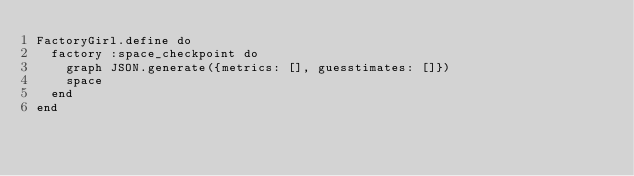<code> <loc_0><loc_0><loc_500><loc_500><_Ruby_>FactoryGirl.define do
  factory :space_checkpoint do
    graph JSON.generate({metrics: [], guesstimates: []})
    space
  end
end
</code> 